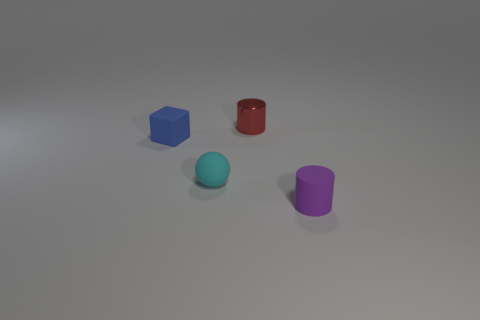Are there fewer tiny cyan things left of the tiny matte sphere than green cylinders? no 